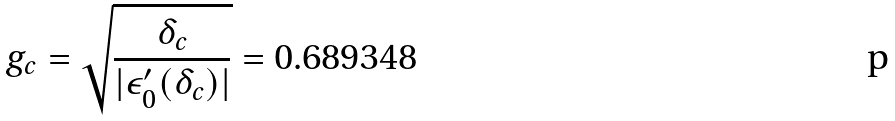Convert formula to latex. <formula><loc_0><loc_0><loc_500><loc_500>g _ { c } = \sqrt { \frac { \delta _ { c } } { | \epsilon _ { 0 } ^ { \prime } ( \delta _ { c } ) | } } = 0 . 6 8 9 3 4 8</formula> 